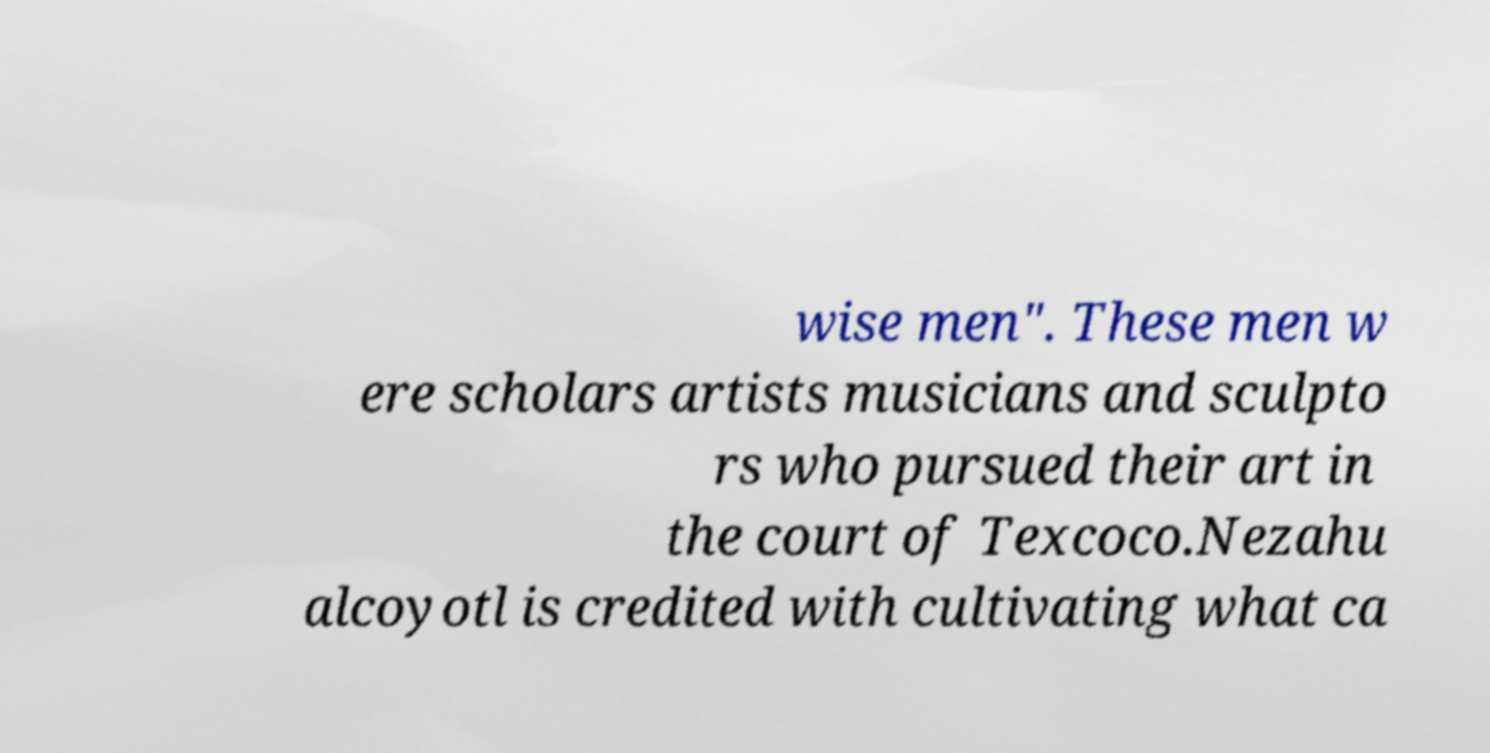Can you read and provide the text displayed in the image?This photo seems to have some interesting text. Can you extract and type it out for me? wise men". These men w ere scholars artists musicians and sculpto rs who pursued their art in the court of Texcoco.Nezahu alcoyotl is credited with cultivating what ca 